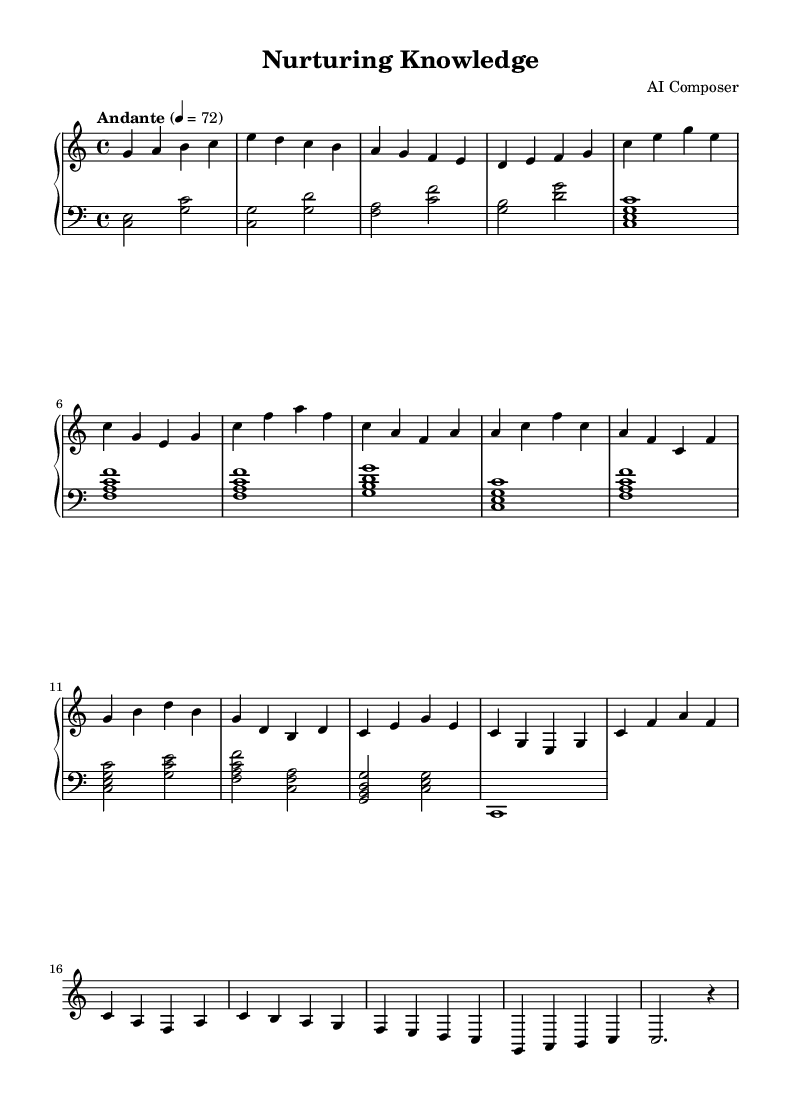What is the key signature of this music? The piece is in C major, as indicated by the absence of sharp or flat symbols in the key signature at the beginning of the staff.
Answer: C major What is the time signature of this composition? The time signature is indicated at the beginning of the piece as 4/4, which means there are four beats in each measure and the quarter note receives one beat.
Answer: 4/4 What tempo marking is given for this piece? The tempo marking is "Andante," which suggests a moderately slow tempo, typically around 76-108 beats per minute; the specific marking given is 4 = 72.
Answer: Andante How many themes are present in the music? There are three main themes identified in the sheet music: Theme A, Theme B, and Theme A' (the repeat of Theme A).
Answer: Three What is the first note played in the left hand? The first note in the left hand is C, as indicated by the very first note in the score section on the left staff.
Answer: C Which section of the piece includes a Coda? The Coda section is found at the end of the piece, noted in the last few measures after the themes have been presented. This is where the music concludes.
Answer: Coda What chord does the left hand primarily play in Theme A? In Theme A, the left hand primarily plays a C major chord, represented as <c, e, g>. This indicates the notes forming the chord.
Answer: C major chord 